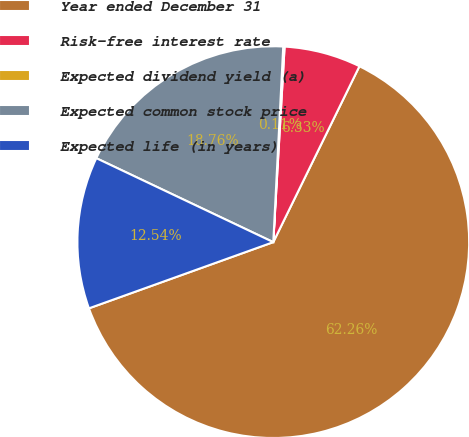<chart> <loc_0><loc_0><loc_500><loc_500><pie_chart><fcel>Year ended December 31<fcel>Risk-free interest rate<fcel>Expected dividend yield (a)<fcel>Expected common stock price<fcel>Expected life (in years)<nl><fcel>62.27%<fcel>6.33%<fcel>0.11%<fcel>18.76%<fcel>12.54%<nl></chart> 